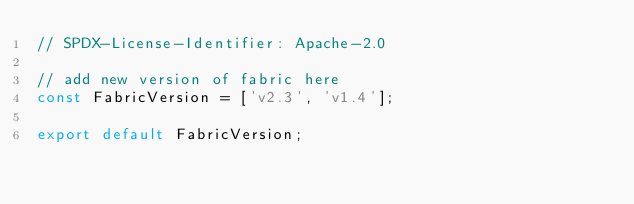<code> <loc_0><loc_0><loc_500><loc_500><_JavaScript_>// SPDX-License-Identifier: Apache-2.0

// add new version of fabric here
const FabricVersion = ['v2.3', 'v1.4'];

export default FabricVersion;
</code> 